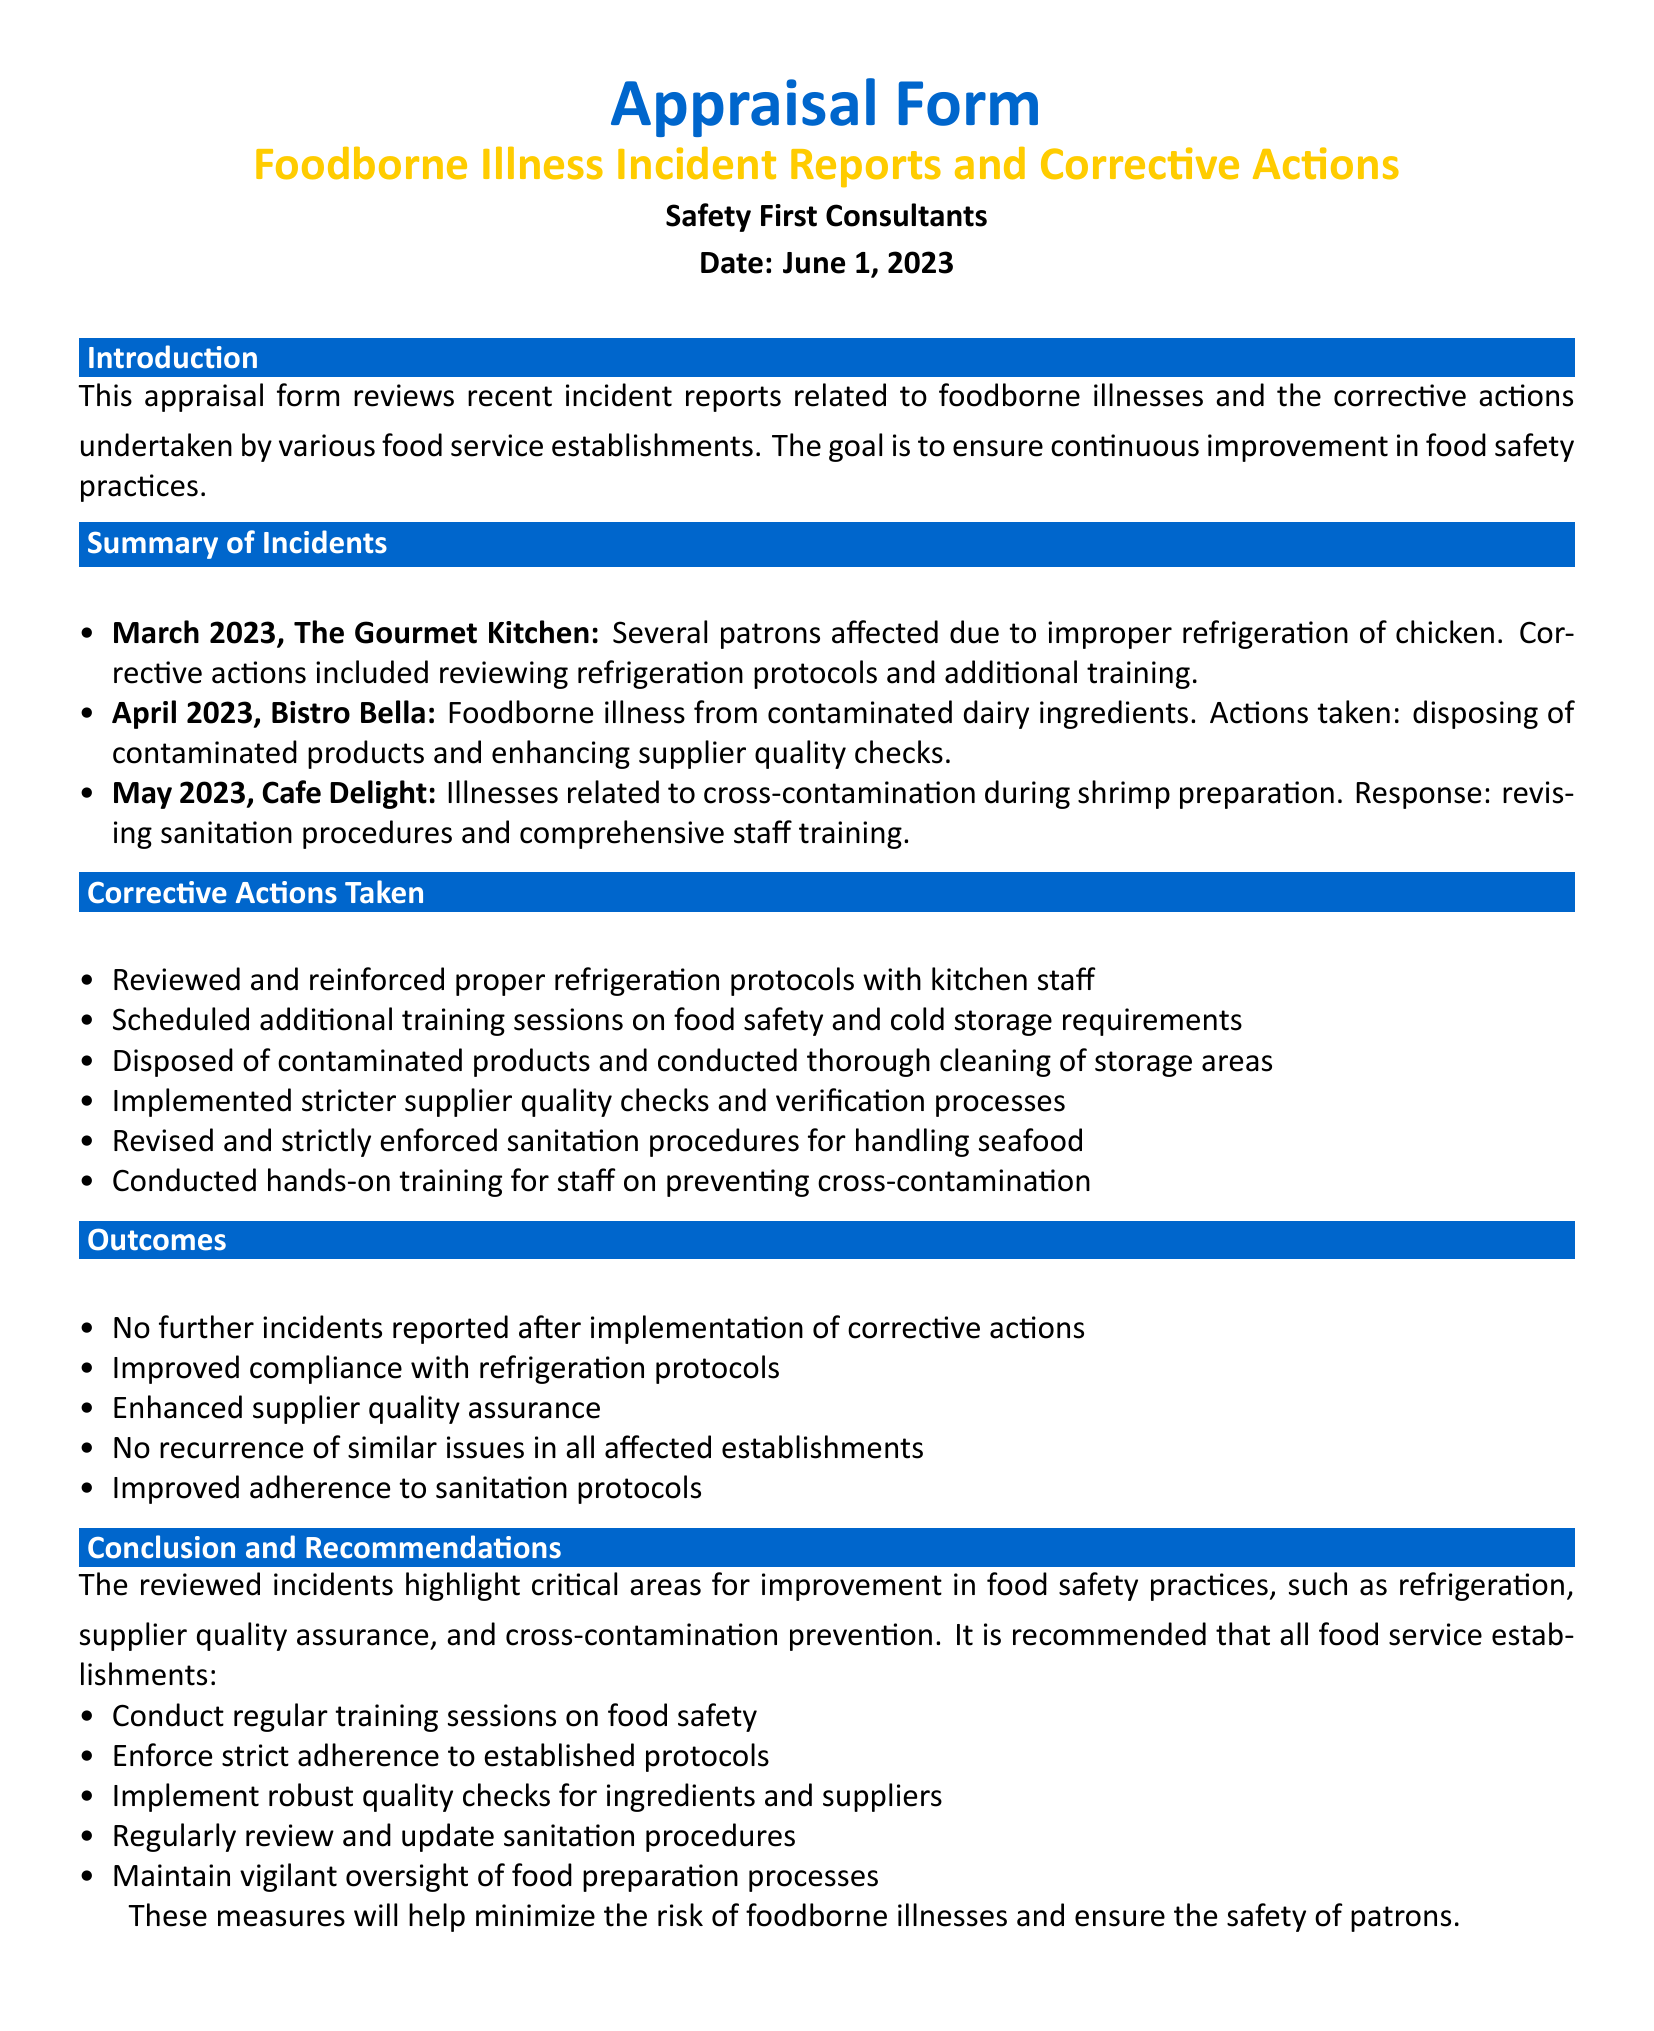What incident occurred in March 2023? The incident in March 2023 involved several patrons affected due to improper refrigeration of chicken at The Gourmet Kitchen.
Answer: Improper refrigeration of chicken What corrective action was taken in April 2023? In April 2023, corrective actions included disposing of contaminated products and enhancing supplier quality checks at Bistro Bella.
Answer: Disposing of contaminated products How many incidents are summarized in the document? The document summarizes three incidents related to foodborne illnesses.
Answer: Three When was the appraisal form dated? The appraisal form is dated June 1, 2023, as stated in the header of the document.
Answer: June 1, 2023 What was a recommended action for food service establishments? The document recommends conducting regular training sessions on food safety as a proactive measure.
Answer: Conduct regular training sessions What was the outcome reported after implementation of corrective actions? The document states that there were no further incidents reported after the implementation of corrective actions.
Answer: No further incidents reported Which establishment experienced issues related to cross-contamination? Cafe Delight experienced issues related to cross-contamination during shrimp preparation as noted in the summary of incidents.
Answer: Cafe Delight What color is used for the main title in the document? The main title is colored in RGB(0, 102, 204), indicated in the design specifications.
Answer: RGB(0, 102, 204) 